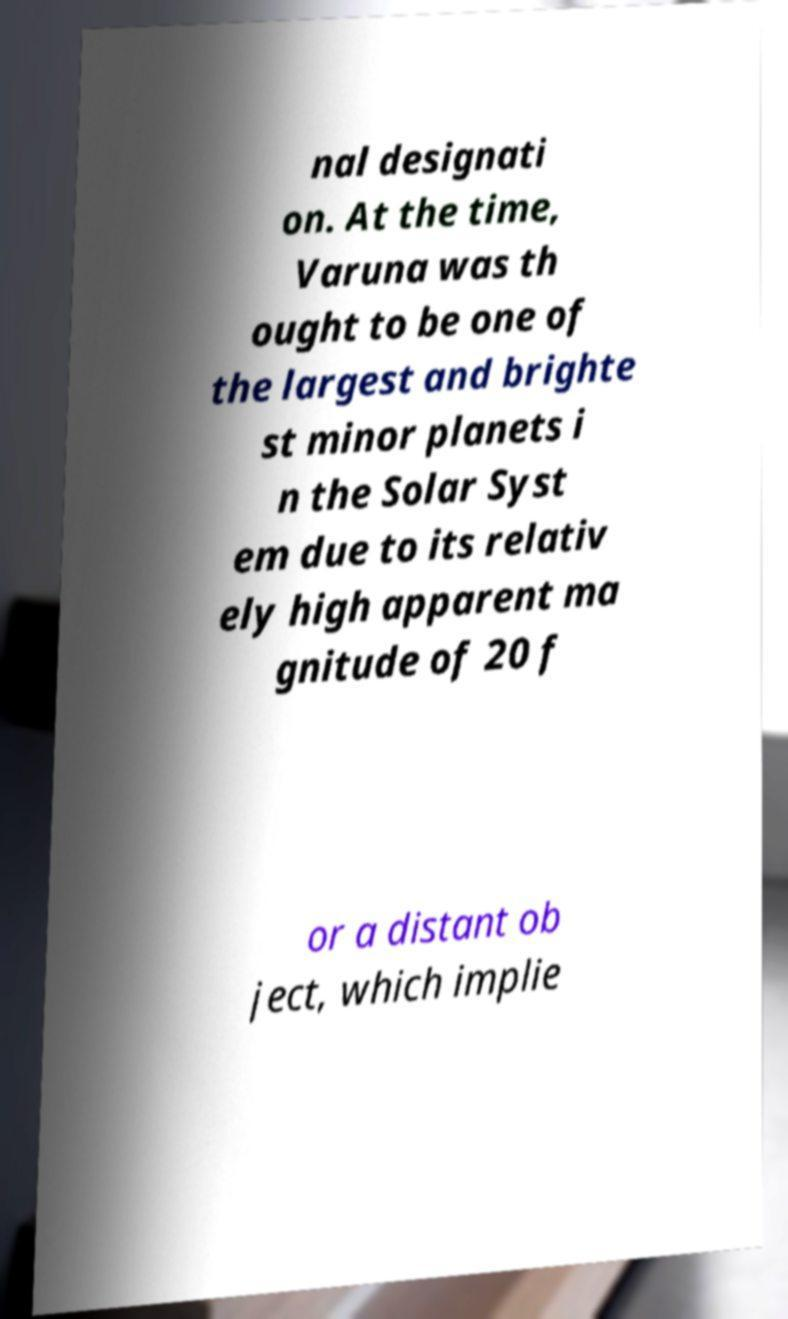Could you assist in decoding the text presented in this image and type it out clearly? nal designati on. At the time, Varuna was th ought to be one of the largest and brighte st minor planets i n the Solar Syst em due to its relativ ely high apparent ma gnitude of 20 f or a distant ob ject, which implie 